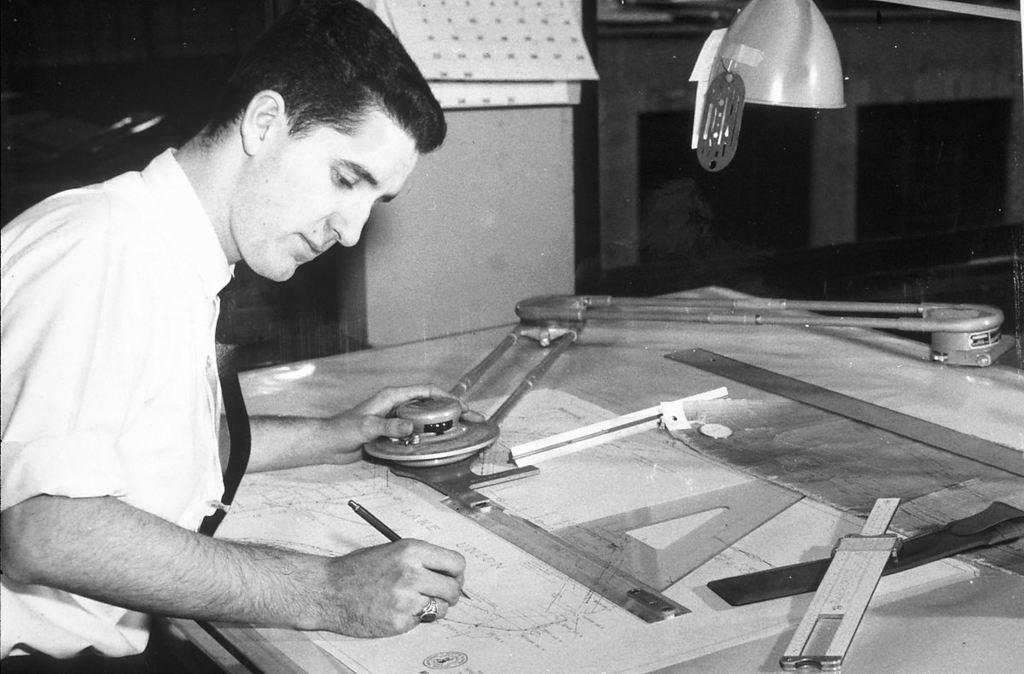Could you give a brief overview of what you see in this image? In the picture there is a man, in front of the man there is a table, on the table we can see the papers, scales. 